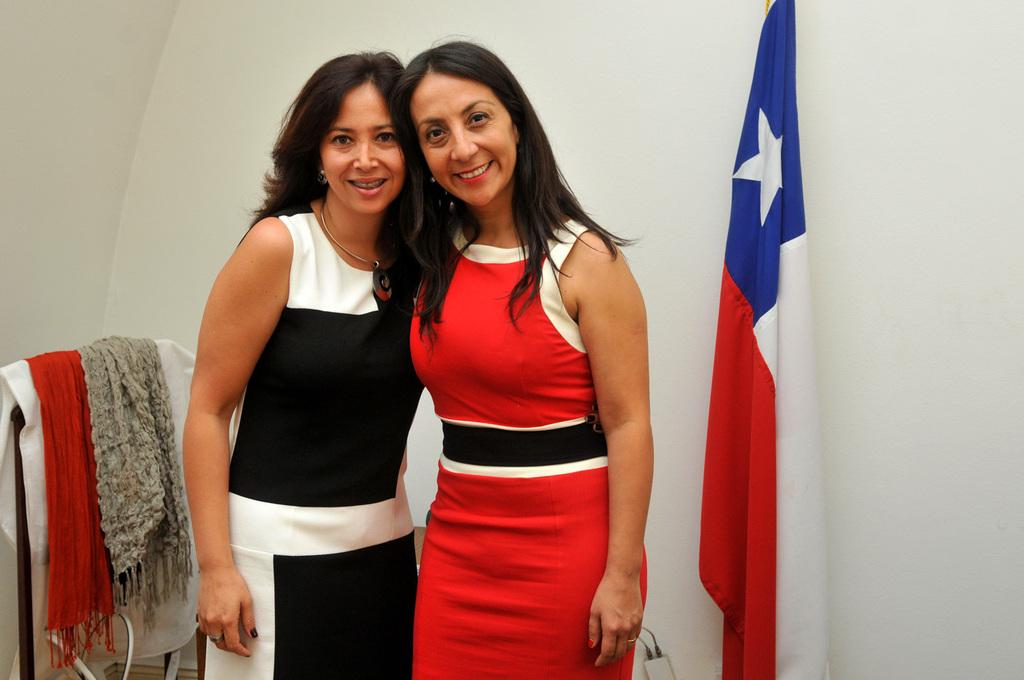How many people are in the image? There are two women standing in the image. What is located to the right of the women? There is a flag to the right of the women. What can be seen to the left of the women? There are scarfs on a stand to the left of the women. What is visible behind the women? There is a wall visible behind the women. What type of cannon is being fired in the image? There is no cannon present in the image. How does the burst of color enhance the image? There is no mention of a burst of color in the image, as it only features two women, a flag, scarfs on a stand, and a wall. 